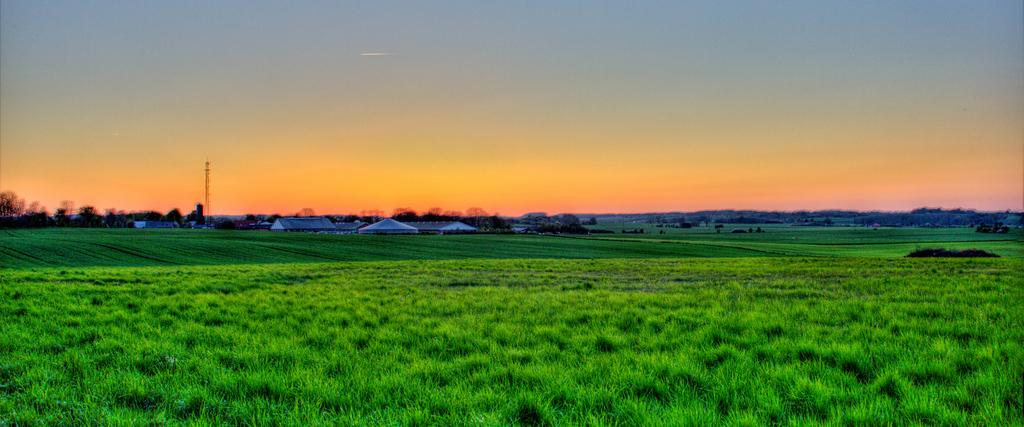What is the ground covered with in the image? The ground is covered in greenery. What can be seen in the background of the image? There are buildings and trees in the background of the image. Where is the recess located in the image? There is no recess present in the image. What type of rail can be seen in the image? There is no rail present in the image. 